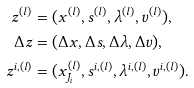<formula> <loc_0><loc_0><loc_500><loc_500>z ^ { ( l ) } & = ( x ^ { ( l ) } , s ^ { ( l ) } , \lambda ^ { ( l ) } , v ^ { ( l ) } ) , \\ \Delta z & = ( \Delta x , \Delta s , \Delta \lambda , \Delta v ) , \\ z ^ { i , ( l ) } & = ( x _ { J _ { i } } ^ { ( l ) } , s ^ { i , ( l ) } , \lambda ^ { i , ( l ) } , v ^ { i , ( l ) } ) .</formula> 